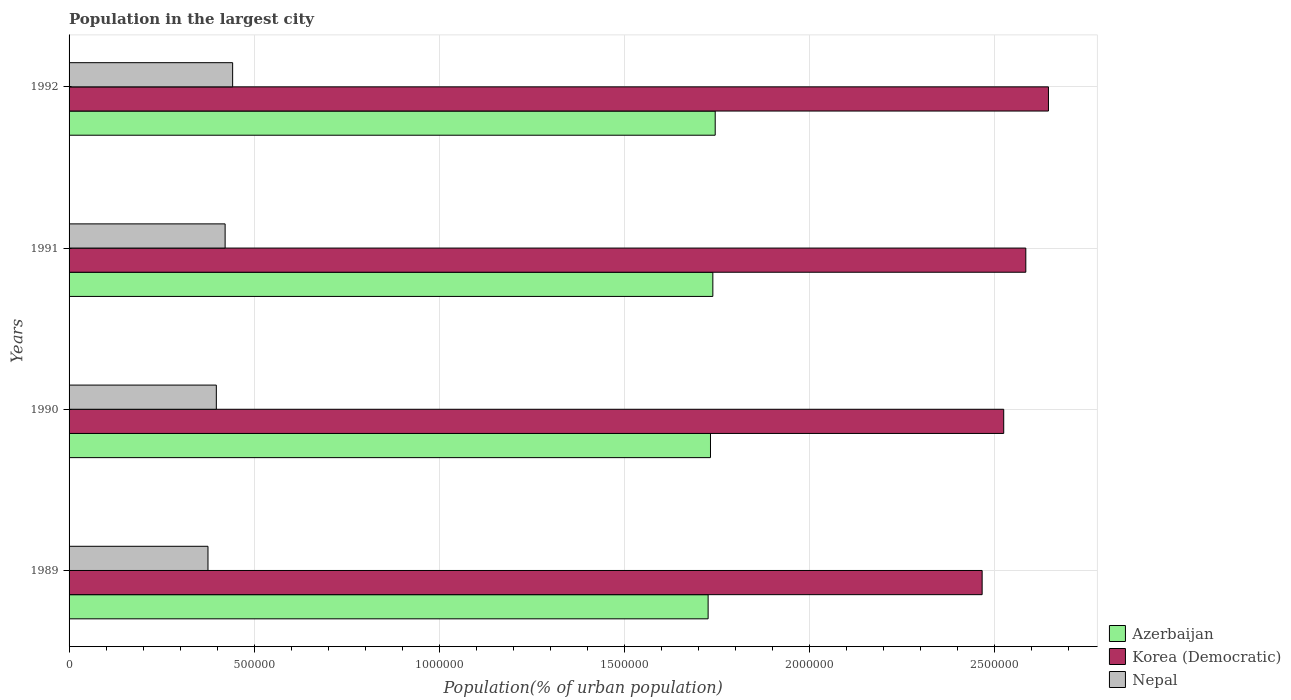How many groups of bars are there?
Make the answer very short. 4. Are the number of bars per tick equal to the number of legend labels?
Your response must be concise. Yes. How many bars are there on the 2nd tick from the bottom?
Provide a succinct answer. 3. In how many cases, is the number of bars for a given year not equal to the number of legend labels?
Offer a terse response. 0. What is the population in the largest city in Azerbaijan in 1989?
Offer a very short reply. 1.73e+06. Across all years, what is the maximum population in the largest city in Nepal?
Make the answer very short. 4.42e+05. Across all years, what is the minimum population in the largest city in Azerbaijan?
Offer a very short reply. 1.73e+06. In which year was the population in the largest city in Nepal maximum?
Your answer should be compact. 1992. What is the total population in the largest city in Azerbaijan in the graph?
Offer a terse response. 6.95e+06. What is the difference between the population in the largest city in Korea (Democratic) in 1989 and that in 1991?
Give a very brief answer. -1.18e+05. What is the difference between the population in the largest city in Nepal in 1992 and the population in the largest city in Azerbaijan in 1991?
Keep it short and to the point. -1.30e+06. What is the average population in the largest city in Korea (Democratic) per year?
Make the answer very short. 2.56e+06. In the year 1991, what is the difference between the population in the largest city in Azerbaijan and population in the largest city in Korea (Democratic)?
Offer a very short reply. -8.46e+05. In how many years, is the population in the largest city in Korea (Democratic) greater than 600000 %?
Offer a very short reply. 4. What is the ratio of the population in the largest city in Azerbaijan in 1991 to that in 1992?
Provide a short and direct response. 1. Is the difference between the population in the largest city in Azerbaijan in 1991 and 1992 greater than the difference between the population in the largest city in Korea (Democratic) in 1991 and 1992?
Your response must be concise. Yes. What is the difference between the highest and the second highest population in the largest city in Korea (Democratic)?
Make the answer very short. 6.12e+04. What is the difference between the highest and the lowest population in the largest city in Korea (Democratic)?
Provide a short and direct response. 1.79e+05. In how many years, is the population in the largest city in Azerbaijan greater than the average population in the largest city in Azerbaijan taken over all years?
Provide a succinct answer. 2. Is the sum of the population in the largest city in Azerbaijan in 1990 and 1992 greater than the maximum population in the largest city in Korea (Democratic) across all years?
Ensure brevity in your answer.  Yes. What does the 1st bar from the top in 1991 represents?
Offer a very short reply. Nepal. What does the 2nd bar from the bottom in 1991 represents?
Provide a short and direct response. Korea (Democratic). Is it the case that in every year, the sum of the population in the largest city in Azerbaijan and population in the largest city in Nepal is greater than the population in the largest city in Korea (Democratic)?
Offer a terse response. No. Does the graph contain any zero values?
Offer a very short reply. No. Does the graph contain grids?
Your response must be concise. Yes. How many legend labels are there?
Offer a terse response. 3. How are the legend labels stacked?
Provide a succinct answer. Vertical. What is the title of the graph?
Provide a short and direct response. Population in the largest city. Does "Mauritania" appear as one of the legend labels in the graph?
Provide a succinct answer. No. What is the label or title of the X-axis?
Provide a succinct answer. Population(% of urban population). What is the Population(% of urban population) in Azerbaijan in 1989?
Provide a succinct answer. 1.73e+06. What is the Population(% of urban population) of Korea (Democratic) in 1989?
Provide a short and direct response. 2.47e+06. What is the Population(% of urban population) of Nepal in 1989?
Offer a terse response. 3.75e+05. What is the Population(% of urban population) of Azerbaijan in 1990?
Offer a very short reply. 1.73e+06. What is the Population(% of urban population) in Korea (Democratic) in 1990?
Your response must be concise. 2.53e+06. What is the Population(% of urban population) in Nepal in 1990?
Offer a terse response. 3.98e+05. What is the Population(% of urban population) in Azerbaijan in 1991?
Keep it short and to the point. 1.74e+06. What is the Population(% of urban population) of Korea (Democratic) in 1991?
Your answer should be compact. 2.59e+06. What is the Population(% of urban population) in Nepal in 1991?
Ensure brevity in your answer.  4.22e+05. What is the Population(% of urban population) in Azerbaijan in 1992?
Your response must be concise. 1.75e+06. What is the Population(% of urban population) of Korea (Democratic) in 1992?
Provide a short and direct response. 2.65e+06. What is the Population(% of urban population) of Nepal in 1992?
Your response must be concise. 4.42e+05. Across all years, what is the maximum Population(% of urban population) of Azerbaijan?
Offer a terse response. 1.75e+06. Across all years, what is the maximum Population(% of urban population) of Korea (Democratic)?
Keep it short and to the point. 2.65e+06. Across all years, what is the maximum Population(% of urban population) of Nepal?
Give a very brief answer. 4.42e+05. Across all years, what is the minimum Population(% of urban population) of Azerbaijan?
Offer a very short reply. 1.73e+06. Across all years, what is the minimum Population(% of urban population) of Korea (Democratic)?
Offer a terse response. 2.47e+06. Across all years, what is the minimum Population(% of urban population) in Nepal?
Your response must be concise. 3.75e+05. What is the total Population(% of urban population) of Azerbaijan in the graph?
Your response must be concise. 6.95e+06. What is the total Population(% of urban population) of Korea (Democratic) in the graph?
Offer a terse response. 1.02e+07. What is the total Population(% of urban population) of Nepal in the graph?
Offer a terse response. 1.64e+06. What is the difference between the Population(% of urban population) in Azerbaijan in 1989 and that in 1990?
Ensure brevity in your answer.  -6348. What is the difference between the Population(% of urban population) in Korea (Democratic) in 1989 and that in 1990?
Make the answer very short. -5.83e+04. What is the difference between the Population(% of urban population) of Nepal in 1989 and that in 1990?
Offer a terse response. -2.25e+04. What is the difference between the Population(% of urban population) in Azerbaijan in 1989 and that in 1991?
Provide a short and direct response. -1.27e+04. What is the difference between the Population(% of urban population) in Korea (Democratic) in 1989 and that in 1991?
Give a very brief answer. -1.18e+05. What is the difference between the Population(% of urban population) of Nepal in 1989 and that in 1991?
Your answer should be very brief. -4.63e+04. What is the difference between the Population(% of urban population) of Azerbaijan in 1989 and that in 1992?
Make the answer very short. -1.91e+04. What is the difference between the Population(% of urban population) in Korea (Democratic) in 1989 and that in 1992?
Your answer should be very brief. -1.79e+05. What is the difference between the Population(% of urban population) in Nepal in 1989 and that in 1992?
Ensure brevity in your answer.  -6.66e+04. What is the difference between the Population(% of urban population) of Azerbaijan in 1990 and that in 1991?
Your answer should be compact. -6371. What is the difference between the Population(% of urban population) of Korea (Democratic) in 1990 and that in 1991?
Your response must be concise. -5.97e+04. What is the difference between the Population(% of urban population) in Nepal in 1990 and that in 1991?
Give a very brief answer. -2.38e+04. What is the difference between the Population(% of urban population) of Azerbaijan in 1990 and that in 1992?
Provide a short and direct response. -1.28e+04. What is the difference between the Population(% of urban population) in Korea (Democratic) in 1990 and that in 1992?
Provide a succinct answer. -1.21e+05. What is the difference between the Population(% of urban population) of Nepal in 1990 and that in 1992?
Provide a succinct answer. -4.41e+04. What is the difference between the Population(% of urban population) in Azerbaijan in 1991 and that in 1992?
Offer a very short reply. -6403. What is the difference between the Population(% of urban population) in Korea (Democratic) in 1991 and that in 1992?
Your answer should be compact. -6.12e+04. What is the difference between the Population(% of urban population) in Nepal in 1991 and that in 1992?
Offer a very short reply. -2.03e+04. What is the difference between the Population(% of urban population) in Azerbaijan in 1989 and the Population(% of urban population) in Korea (Democratic) in 1990?
Make the answer very short. -7.99e+05. What is the difference between the Population(% of urban population) in Azerbaijan in 1989 and the Population(% of urban population) in Nepal in 1990?
Your answer should be compact. 1.33e+06. What is the difference between the Population(% of urban population) in Korea (Democratic) in 1989 and the Population(% of urban population) in Nepal in 1990?
Offer a terse response. 2.07e+06. What is the difference between the Population(% of urban population) of Azerbaijan in 1989 and the Population(% of urban population) of Korea (Democratic) in 1991?
Your answer should be very brief. -8.59e+05. What is the difference between the Population(% of urban population) of Azerbaijan in 1989 and the Population(% of urban population) of Nepal in 1991?
Provide a short and direct response. 1.31e+06. What is the difference between the Population(% of urban population) of Korea (Democratic) in 1989 and the Population(% of urban population) of Nepal in 1991?
Your answer should be compact. 2.05e+06. What is the difference between the Population(% of urban population) of Azerbaijan in 1989 and the Population(% of urban population) of Korea (Democratic) in 1992?
Provide a short and direct response. -9.20e+05. What is the difference between the Population(% of urban population) in Azerbaijan in 1989 and the Population(% of urban population) in Nepal in 1992?
Offer a very short reply. 1.29e+06. What is the difference between the Population(% of urban population) of Korea (Democratic) in 1989 and the Population(% of urban population) of Nepal in 1992?
Provide a short and direct response. 2.03e+06. What is the difference between the Population(% of urban population) of Azerbaijan in 1990 and the Population(% of urban population) of Korea (Democratic) in 1991?
Offer a very short reply. -8.52e+05. What is the difference between the Population(% of urban population) of Azerbaijan in 1990 and the Population(% of urban population) of Nepal in 1991?
Provide a short and direct response. 1.31e+06. What is the difference between the Population(% of urban population) in Korea (Democratic) in 1990 and the Population(% of urban population) in Nepal in 1991?
Offer a very short reply. 2.10e+06. What is the difference between the Population(% of urban population) in Azerbaijan in 1990 and the Population(% of urban population) in Korea (Democratic) in 1992?
Your response must be concise. -9.13e+05. What is the difference between the Population(% of urban population) in Azerbaijan in 1990 and the Population(% of urban population) in Nepal in 1992?
Make the answer very short. 1.29e+06. What is the difference between the Population(% of urban population) in Korea (Democratic) in 1990 and the Population(% of urban population) in Nepal in 1992?
Provide a succinct answer. 2.08e+06. What is the difference between the Population(% of urban population) of Azerbaijan in 1991 and the Population(% of urban population) of Korea (Democratic) in 1992?
Provide a succinct answer. -9.07e+05. What is the difference between the Population(% of urban population) of Azerbaijan in 1991 and the Population(% of urban population) of Nepal in 1992?
Your answer should be very brief. 1.30e+06. What is the difference between the Population(% of urban population) in Korea (Democratic) in 1991 and the Population(% of urban population) in Nepal in 1992?
Give a very brief answer. 2.14e+06. What is the average Population(% of urban population) of Azerbaijan per year?
Provide a short and direct response. 1.74e+06. What is the average Population(% of urban population) of Korea (Democratic) per year?
Your response must be concise. 2.56e+06. What is the average Population(% of urban population) of Nepal per year?
Provide a short and direct response. 4.09e+05. In the year 1989, what is the difference between the Population(% of urban population) in Azerbaijan and Population(% of urban population) in Korea (Democratic)?
Give a very brief answer. -7.41e+05. In the year 1989, what is the difference between the Population(% of urban population) in Azerbaijan and Population(% of urban population) in Nepal?
Offer a very short reply. 1.35e+06. In the year 1989, what is the difference between the Population(% of urban population) in Korea (Democratic) and Population(% of urban population) in Nepal?
Offer a terse response. 2.09e+06. In the year 1990, what is the difference between the Population(% of urban population) of Azerbaijan and Population(% of urban population) of Korea (Democratic)?
Offer a terse response. -7.93e+05. In the year 1990, what is the difference between the Population(% of urban population) in Azerbaijan and Population(% of urban population) in Nepal?
Give a very brief answer. 1.34e+06. In the year 1990, what is the difference between the Population(% of urban population) in Korea (Democratic) and Population(% of urban population) in Nepal?
Give a very brief answer. 2.13e+06. In the year 1991, what is the difference between the Population(% of urban population) in Azerbaijan and Population(% of urban population) in Korea (Democratic)?
Offer a terse response. -8.46e+05. In the year 1991, what is the difference between the Population(% of urban population) in Azerbaijan and Population(% of urban population) in Nepal?
Your answer should be very brief. 1.32e+06. In the year 1991, what is the difference between the Population(% of urban population) of Korea (Democratic) and Population(% of urban population) of Nepal?
Provide a succinct answer. 2.16e+06. In the year 1992, what is the difference between the Population(% of urban population) in Azerbaijan and Population(% of urban population) in Korea (Democratic)?
Provide a short and direct response. -9.01e+05. In the year 1992, what is the difference between the Population(% of urban population) in Azerbaijan and Population(% of urban population) in Nepal?
Provide a succinct answer. 1.30e+06. In the year 1992, what is the difference between the Population(% of urban population) in Korea (Democratic) and Population(% of urban population) in Nepal?
Offer a terse response. 2.20e+06. What is the ratio of the Population(% of urban population) in Azerbaijan in 1989 to that in 1990?
Give a very brief answer. 1. What is the ratio of the Population(% of urban population) in Korea (Democratic) in 1989 to that in 1990?
Your answer should be compact. 0.98. What is the ratio of the Population(% of urban population) of Nepal in 1989 to that in 1990?
Your answer should be very brief. 0.94. What is the ratio of the Population(% of urban population) in Azerbaijan in 1989 to that in 1991?
Offer a very short reply. 0.99. What is the ratio of the Population(% of urban population) of Korea (Democratic) in 1989 to that in 1991?
Offer a very short reply. 0.95. What is the ratio of the Population(% of urban population) of Nepal in 1989 to that in 1991?
Provide a succinct answer. 0.89. What is the ratio of the Population(% of urban population) in Azerbaijan in 1989 to that in 1992?
Make the answer very short. 0.99. What is the ratio of the Population(% of urban population) in Korea (Democratic) in 1989 to that in 1992?
Ensure brevity in your answer.  0.93. What is the ratio of the Population(% of urban population) of Nepal in 1989 to that in 1992?
Ensure brevity in your answer.  0.85. What is the ratio of the Population(% of urban population) in Azerbaijan in 1990 to that in 1991?
Make the answer very short. 1. What is the ratio of the Population(% of urban population) in Korea (Democratic) in 1990 to that in 1991?
Give a very brief answer. 0.98. What is the ratio of the Population(% of urban population) of Nepal in 1990 to that in 1991?
Provide a succinct answer. 0.94. What is the ratio of the Population(% of urban population) in Azerbaijan in 1990 to that in 1992?
Provide a short and direct response. 0.99. What is the ratio of the Population(% of urban population) in Korea (Democratic) in 1990 to that in 1992?
Ensure brevity in your answer.  0.95. What is the ratio of the Population(% of urban population) in Nepal in 1990 to that in 1992?
Make the answer very short. 0.9. What is the ratio of the Population(% of urban population) in Azerbaijan in 1991 to that in 1992?
Your answer should be very brief. 1. What is the ratio of the Population(% of urban population) of Korea (Democratic) in 1991 to that in 1992?
Provide a short and direct response. 0.98. What is the ratio of the Population(% of urban population) of Nepal in 1991 to that in 1992?
Offer a very short reply. 0.95. What is the difference between the highest and the second highest Population(% of urban population) of Azerbaijan?
Give a very brief answer. 6403. What is the difference between the highest and the second highest Population(% of urban population) of Korea (Democratic)?
Keep it short and to the point. 6.12e+04. What is the difference between the highest and the second highest Population(% of urban population) of Nepal?
Your response must be concise. 2.03e+04. What is the difference between the highest and the lowest Population(% of urban population) in Azerbaijan?
Offer a very short reply. 1.91e+04. What is the difference between the highest and the lowest Population(% of urban population) in Korea (Democratic)?
Offer a very short reply. 1.79e+05. What is the difference between the highest and the lowest Population(% of urban population) in Nepal?
Offer a very short reply. 6.66e+04. 